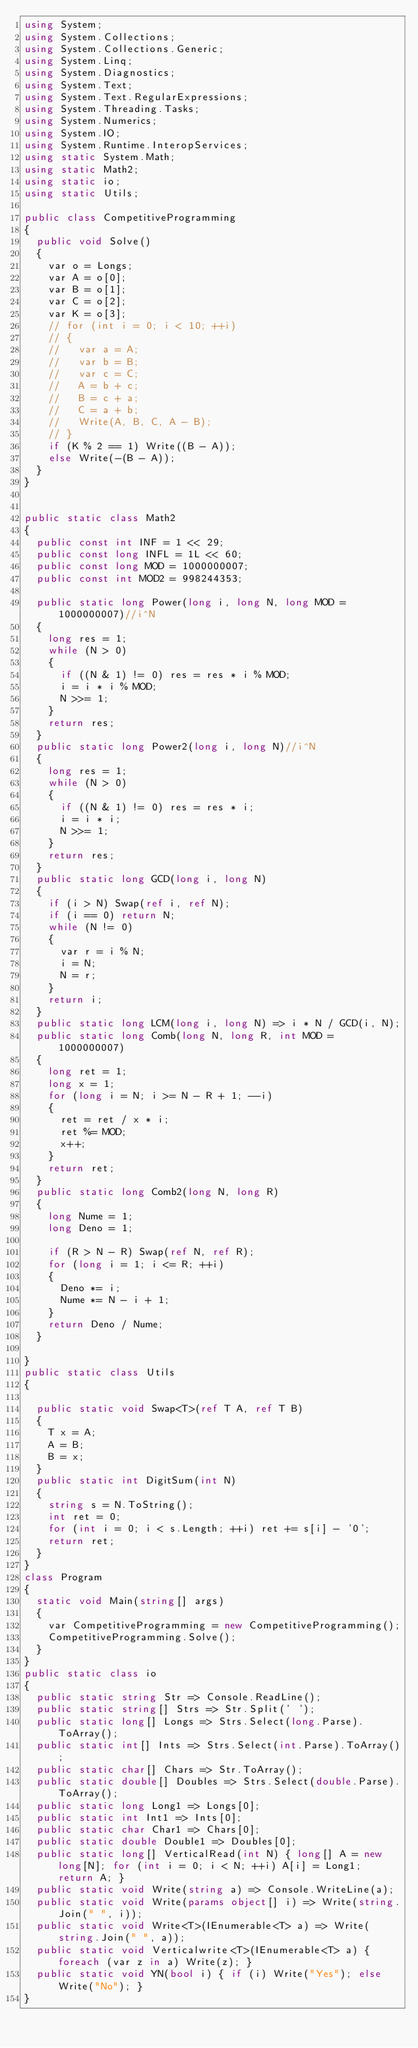Convert code to text. <code><loc_0><loc_0><loc_500><loc_500><_C#_>using System;
using System.Collections;
using System.Collections.Generic;
using System.Linq;
using System.Diagnostics;
using System.Text;
using System.Text.RegularExpressions;
using System.Threading.Tasks;
using System.Numerics;
using System.IO;
using System.Runtime.InteropServices;
using static System.Math;
using static Math2;
using static io;
using static Utils;

public class CompetitiveProgramming
{
  public void Solve()
  {
    var o = Longs;
    var A = o[0];
    var B = o[1];
    var C = o[2];
    var K = o[3];
    // for (int i = 0; i < 10; ++i)
    // {
    //   var a = A;
    //   var b = B;
    //   var c = C;
    //   A = b + c;
    //   B = c + a;
    //   C = a + b;
    //   Write(A, B, C, A - B);
    // }
    if (K % 2 == 1) Write((B - A));
    else Write(-(B - A));
  }
}


public static class Math2
{
  public const int INF = 1 << 29;
  public const long INFL = 1L << 60;
  public const long MOD = 1000000007;
  public const int MOD2 = 998244353;

  public static long Power(long i, long N, long MOD = 1000000007)//i^N
  {
    long res = 1;
    while (N > 0)
    {
      if ((N & 1) != 0) res = res * i % MOD;
      i = i * i % MOD;
      N >>= 1;
    }
    return res;
  }
  public static long Power2(long i, long N)//i^N
  {
    long res = 1;
    while (N > 0)
    {
      if ((N & 1) != 0) res = res * i;
      i = i * i;
      N >>= 1;
    }
    return res;
  }
  public static long GCD(long i, long N)
  {
    if (i > N) Swap(ref i, ref N);
    if (i == 0) return N;
    while (N != 0)
    {
      var r = i % N;
      i = N;
      N = r;
    }
    return i;
  }
  public static long LCM(long i, long N) => i * N / GCD(i, N);
  public static long Comb(long N, long R, int MOD = 1000000007)
  {
    long ret = 1;
    long x = 1;
    for (long i = N; i >= N - R + 1; --i)
    {
      ret = ret / x * i;
      ret %= MOD;
      x++;
    }
    return ret;
  }
  public static long Comb2(long N, long R)
  {
    long Nume = 1;
    long Deno = 1;

    if (R > N - R) Swap(ref N, ref R);
    for (long i = 1; i <= R; ++i)
    {
      Deno *= i;
      Nume *= N - i + 1;
    }
    return Deno / Nume;
  }

}
public static class Utils
{

  public static void Swap<T>(ref T A, ref T B)
  {
    T x = A;
    A = B;
    B = x;
  }
  public static int DigitSum(int N)
  {
    string s = N.ToString();
    int ret = 0;
    for (int i = 0; i < s.Length; ++i) ret += s[i] - '0';
    return ret;
  }
}
class Program
{
  static void Main(string[] args)
  {
    var CompetitiveProgramming = new CompetitiveProgramming();
    CompetitiveProgramming.Solve();
  }
}
public static class io
{
  public static string Str => Console.ReadLine();
  public static string[] Strs => Str.Split(' ');
  public static long[] Longs => Strs.Select(long.Parse).ToArray();
  public static int[] Ints => Strs.Select(int.Parse).ToArray();
  public static char[] Chars => Str.ToArray();
  public static double[] Doubles => Strs.Select(double.Parse).ToArray();
  public static long Long1 => Longs[0];
  public static int Int1 => Ints[0];
  public static char Char1 => Chars[0];
  public static double Double1 => Doubles[0];
  public static long[] VerticalRead(int N) { long[] A = new long[N]; for (int i = 0; i < N; ++i) A[i] = Long1; return A; }
  public static void Write(string a) => Console.WriteLine(a);
  public static void Write(params object[] i) => Write(string.Join(" ", i));
  public static void Write<T>(IEnumerable<T> a) => Write(string.Join(" ", a));
  public static void Verticalwrite<T>(IEnumerable<T> a) { foreach (var z in a) Write(z); }
  public static void YN(bool i) { if (i) Write("Yes"); else Write("No"); }
}
</code> 